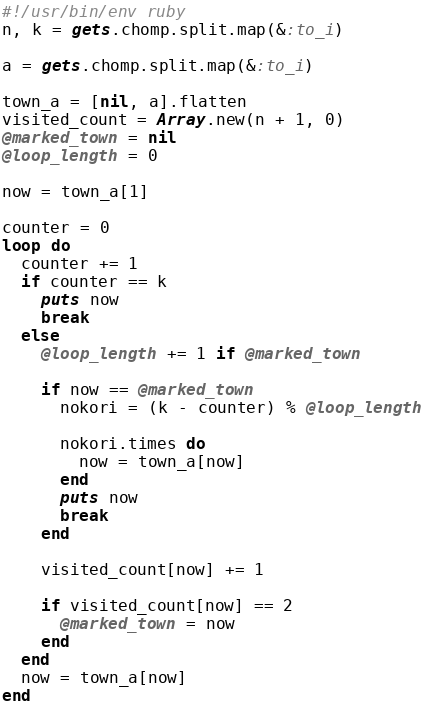<code> <loc_0><loc_0><loc_500><loc_500><_Ruby_>#!/usr/bin/env ruby
n, k = gets.chomp.split.map(&:to_i)

a = gets.chomp.split.map(&:to_i)

town_a = [nil, a].flatten
visited_count = Array.new(n + 1, 0)
@marked_town = nil
@loop_length = 0

now = town_a[1]

counter = 0
loop do
  counter += 1
  if counter == k
    puts now
    break
  else
    @loop_length += 1 if @marked_town

    if now == @marked_town
      nokori = (k - counter) % @loop_length

      nokori.times do
        now = town_a[now]
      end
      puts now
      break
    end

    visited_count[now] += 1

    if visited_count[now] == 2
      @marked_town = now
    end
  end
  now = town_a[now]
end


</code> 